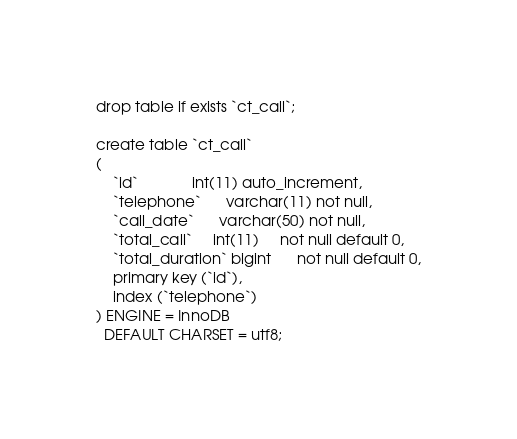<code> <loc_0><loc_0><loc_500><loc_500><_SQL_>drop table if exists `ct_call`;

create table `ct_call`
(
    `id`             int(11) auto_increment,
    `telephone`      varchar(11) not null,
    `call_date`      varchar(50) not null,
    `total_call`     int(11)     not null default 0,
    `total_duration` bigint      not null default 0,
    primary key (`id`),
    index (`telephone`)
) ENGINE = InnoDB
  DEFAULT CHARSET = utf8;</code> 